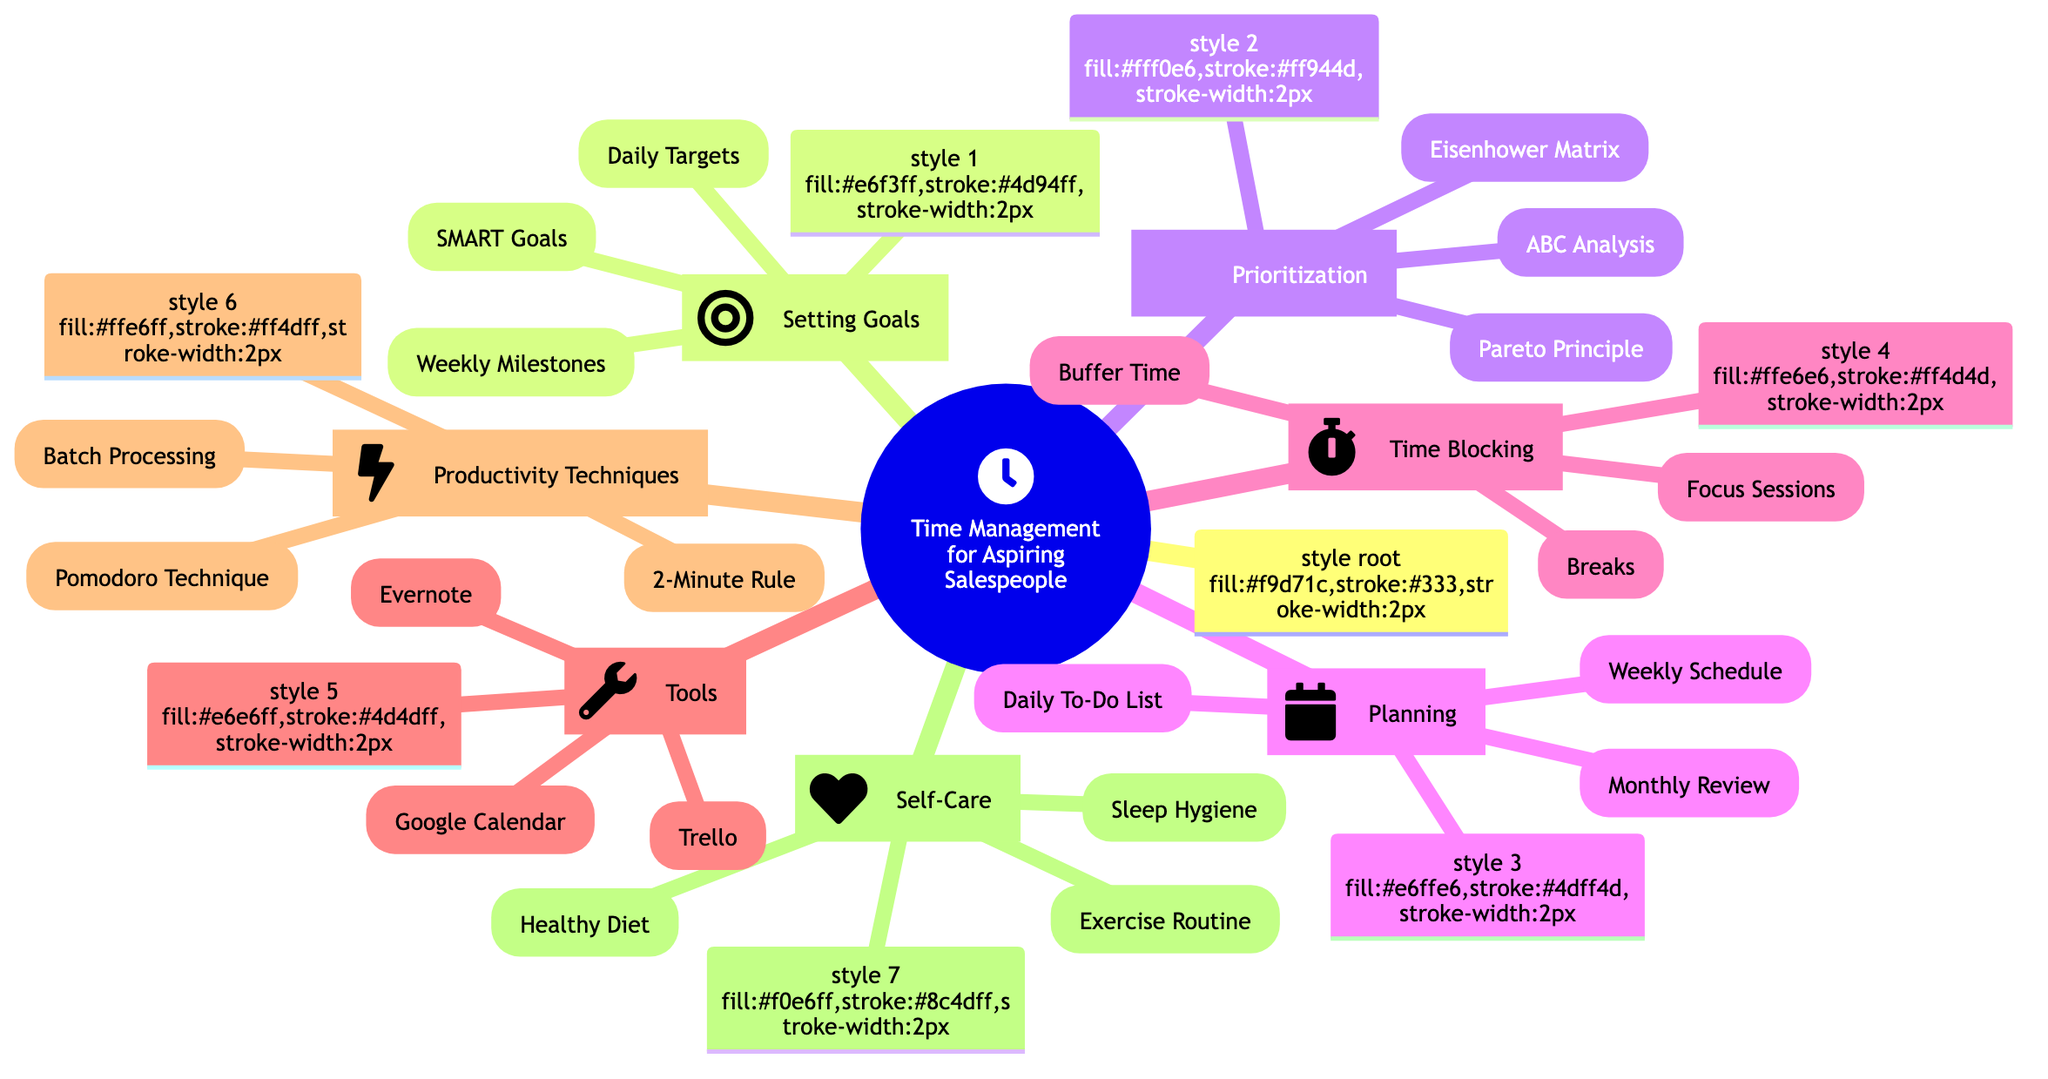What is the main topic of the mind map? The title of the root node indicates that the main topic is "Time Management for Aspiring Salespeople." This information can be found directly at the center of the diagram.
Answer: Time Management for Aspiring Salespeople How many subtopics are there in this mind map? The diagram contains seven subtopics, as seen branching out from the main topic. Each subtopic is represented as a distinct node connected to the root.
Answer: 7 What is one technique listed under "Productivity Techniques"? The diagram includes "Pomodoro Technique" as one of the elements under the "Productivity Techniques" subtopic. This element is specifically listed in the corresponding node.
Answer: Pomodoro Technique Which subtopic includes "Buffer Time"? "Buffer Time" is listed under the subtopic "Time Blocking." By tracing the connections from the root, we can see that it is specifically categorized there.
Answer: Time Blocking According to the diagram, which tool uses a calendar format? "Google Calendar" is mentioned under the "Tools" subtopic, indicating it is one of the tools that utilizes a calendar format for time management.
Answer: Google Calendar Which element is part of both "Setting Goals" and includes a time frame? "Weekly Milestones" is listed under "Setting Goals," indicating it connects goal-setting with time management over a weekly cycle. This element reflects the time frame aspect.
Answer: Weekly Milestones What principle listed under "Prioritization" emphasizes focusing on the most impactful tasks? The "Pareto Principle," also known as the 80/20 rule, is included under "Prioritization" and emphasizes focusing on the tasks that yield the most significant results.
Answer: Pareto Principle Which self-care element emphasizes physical activity? "Exercise Routine" is part of the "Self-Care" subtopic. This element clearly indicates a focus on maintaining physical health as part of time management practices.
Answer: Exercise Routine Identify one technique from the "Planning" subtopic. "Daily To-Do List" is an element included in the "Planning" subtopic, reflecting a specific planning technique helpful for effective time management.
Answer: Daily To-Do List 